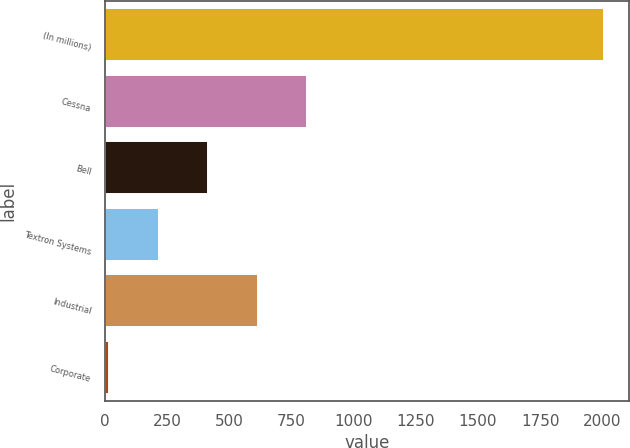Convert chart to OTSL. <chart><loc_0><loc_0><loc_500><loc_500><bar_chart><fcel>(In millions)<fcel>Cessna<fcel>Bell<fcel>Textron Systems<fcel>Industrial<fcel>Corporate<nl><fcel>2007<fcel>813<fcel>415<fcel>216<fcel>614<fcel>17<nl></chart> 